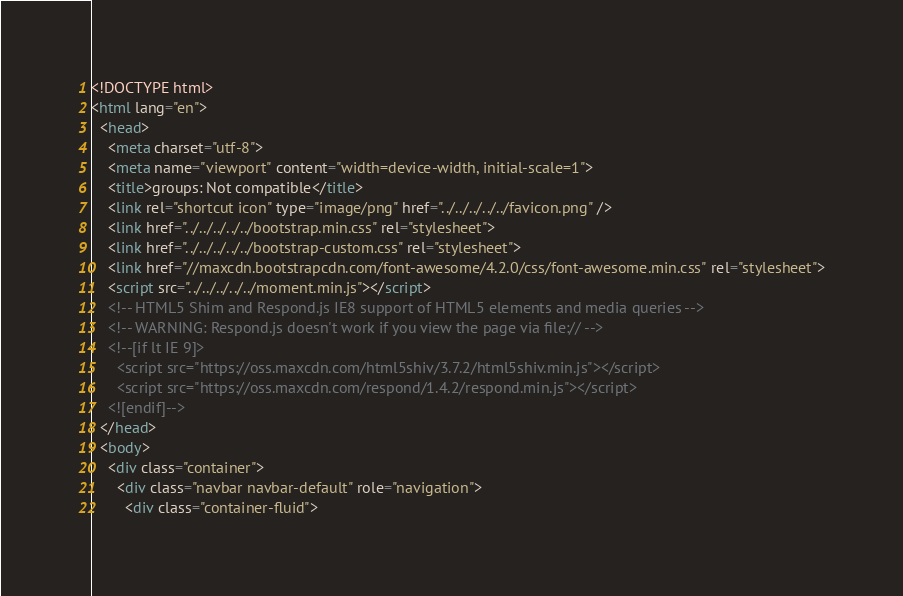Convert code to text. <code><loc_0><loc_0><loc_500><loc_500><_HTML_><!DOCTYPE html>
<html lang="en">
  <head>
    <meta charset="utf-8">
    <meta name="viewport" content="width=device-width, initial-scale=1">
    <title>groups: Not compatible</title>
    <link rel="shortcut icon" type="image/png" href="../../../../../favicon.png" />
    <link href="../../../../../bootstrap.min.css" rel="stylesheet">
    <link href="../../../../../bootstrap-custom.css" rel="stylesheet">
    <link href="//maxcdn.bootstrapcdn.com/font-awesome/4.2.0/css/font-awesome.min.css" rel="stylesheet">
    <script src="../../../../../moment.min.js"></script>
    <!-- HTML5 Shim and Respond.js IE8 support of HTML5 elements and media queries -->
    <!-- WARNING: Respond.js doesn't work if you view the page via file:// -->
    <!--[if lt IE 9]>
      <script src="https://oss.maxcdn.com/html5shiv/3.7.2/html5shiv.min.js"></script>
      <script src="https://oss.maxcdn.com/respond/1.4.2/respond.min.js"></script>
    <![endif]-->
  </head>
  <body>
    <div class="container">
      <div class="navbar navbar-default" role="navigation">
        <div class="container-fluid"></code> 